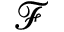<formula> <loc_0><loc_0><loc_500><loc_500>\mathcal { F }</formula> 